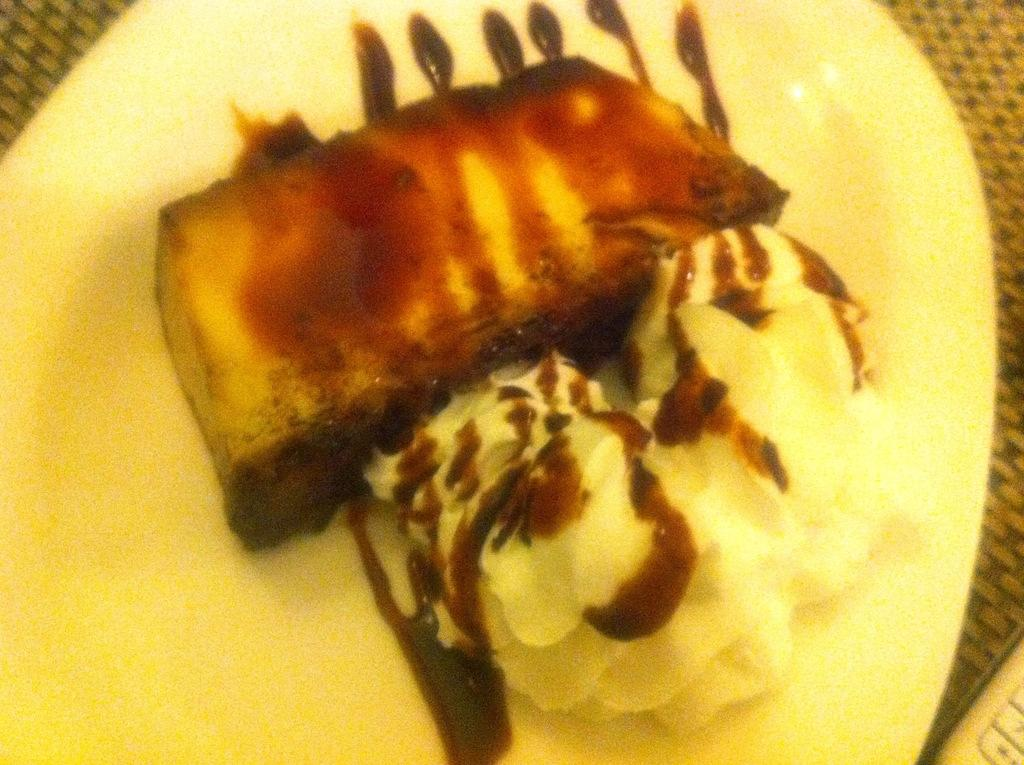What is present on the plate in the image? There is food in a plate in the image. What type of pear is being used as a watch in the image? There is no pear or watch present in the image; it only features food on a plate. 